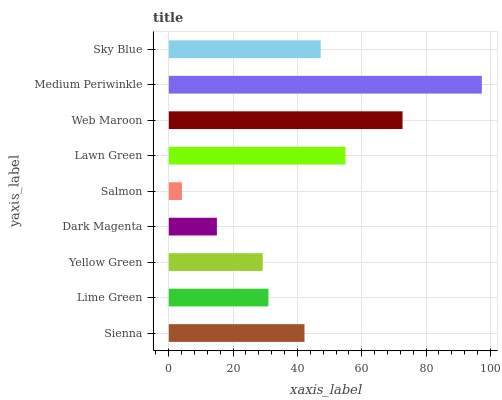Is Salmon the minimum?
Answer yes or no. Yes. Is Medium Periwinkle the maximum?
Answer yes or no. Yes. Is Lime Green the minimum?
Answer yes or no. No. Is Lime Green the maximum?
Answer yes or no. No. Is Sienna greater than Lime Green?
Answer yes or no. Yes. Is Lime Green less than Sienna?
Answer yes or no. Yes. Is Lime Green greater than Sienna?
Answer yes or no. No. Is Sienna less than Lime Green?
Answer yes or no. No. Is Sienna the high median?
Answer yes or no. Yes. Is Sienna the low median?
Answer yes or no. Yes. Is Web Maroon the high median?
Answer yes or no. No. Is Lime Green the low median?
Answer yes or no. No. 